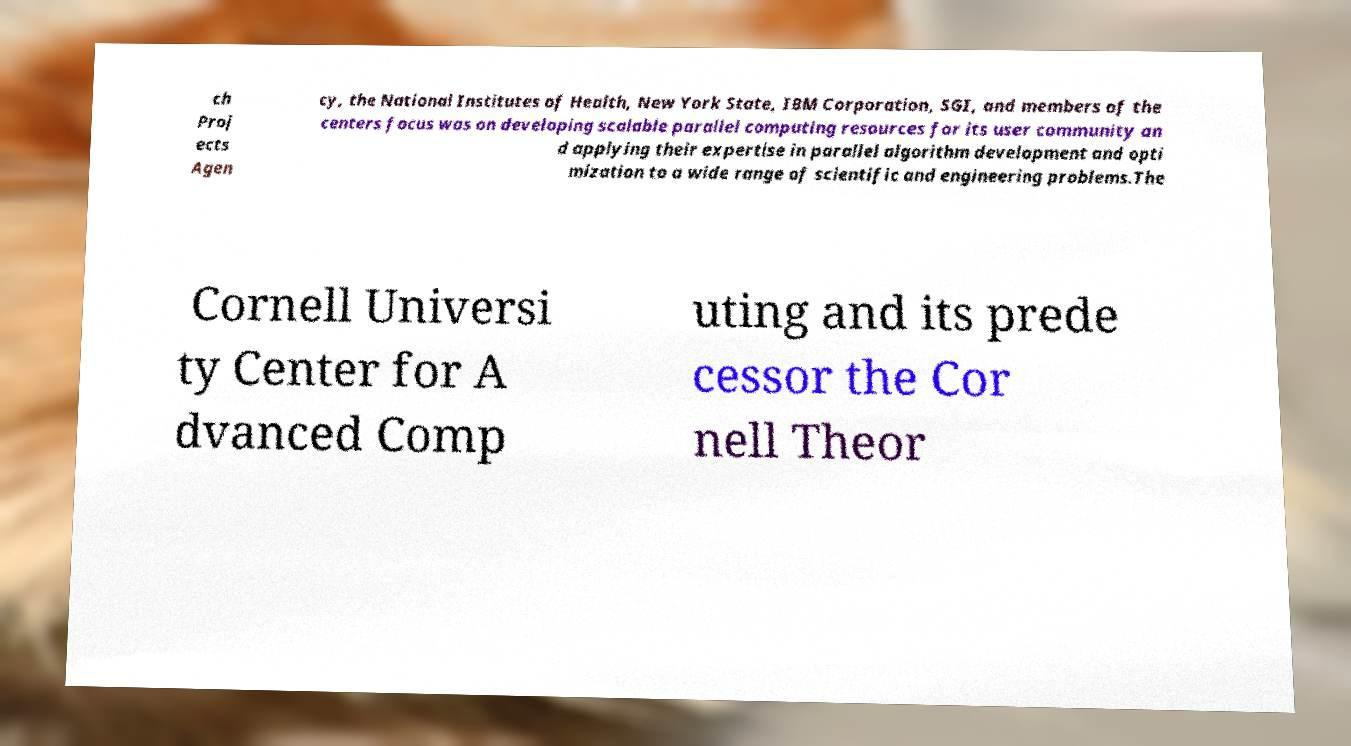Could you extract and type out the text from this image? ch Proj ects Agen cy, the National Institutes of Health, New York State, IBM Corporation, SGI, and members of the centers focus was on developing scalable parallel computing resources for its user community an d applying their expertise in parallel algorithm development and opti mization to a wide range of scientific and engineering problems.The Cornell Universi ty Center for A dvanced Comp uting and its prede cessor the Cor nell Theor 